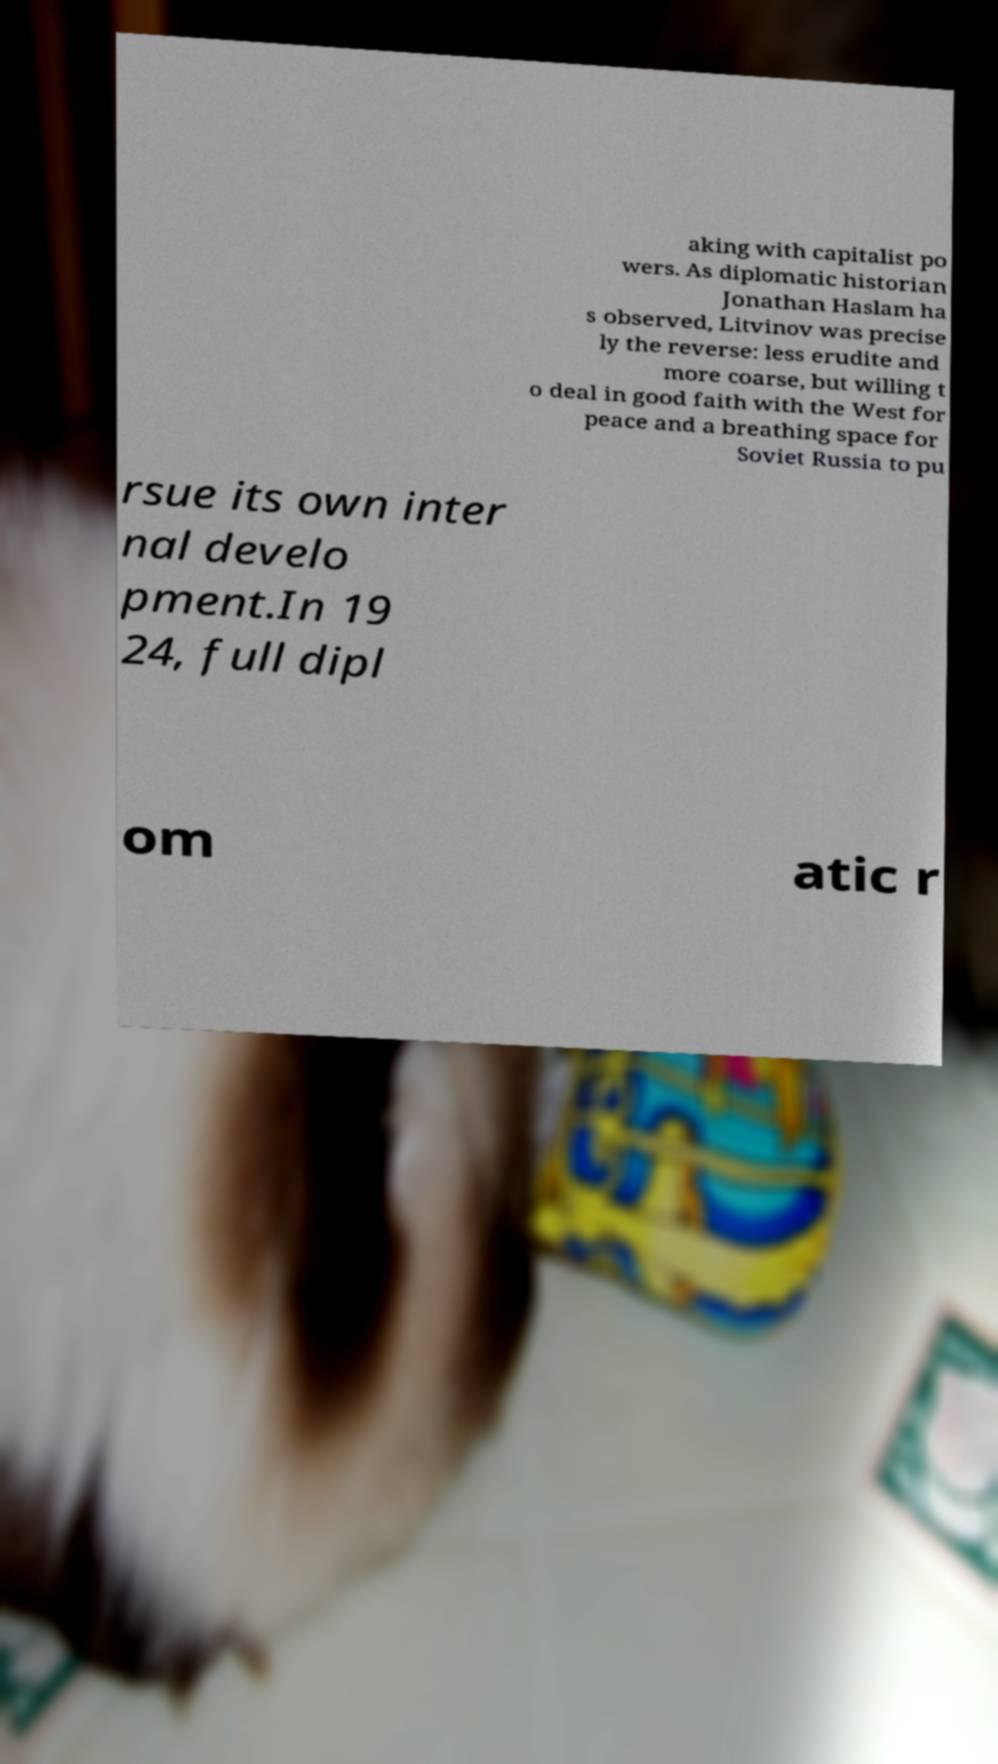Could you assist in decoding the text presented in this image and type it out clearly? aking with capitalist po wers. As diplomatic historian Jonathan Haslam ha s observed, Litvinov was precise ly the reverse: less erudite and more coarse, but willing t o deal in good faith with the West for peace and a breathing space for Soviet Russia to pu rsue its own inter nal develo pment.In 19 24, full dipl om atic r 